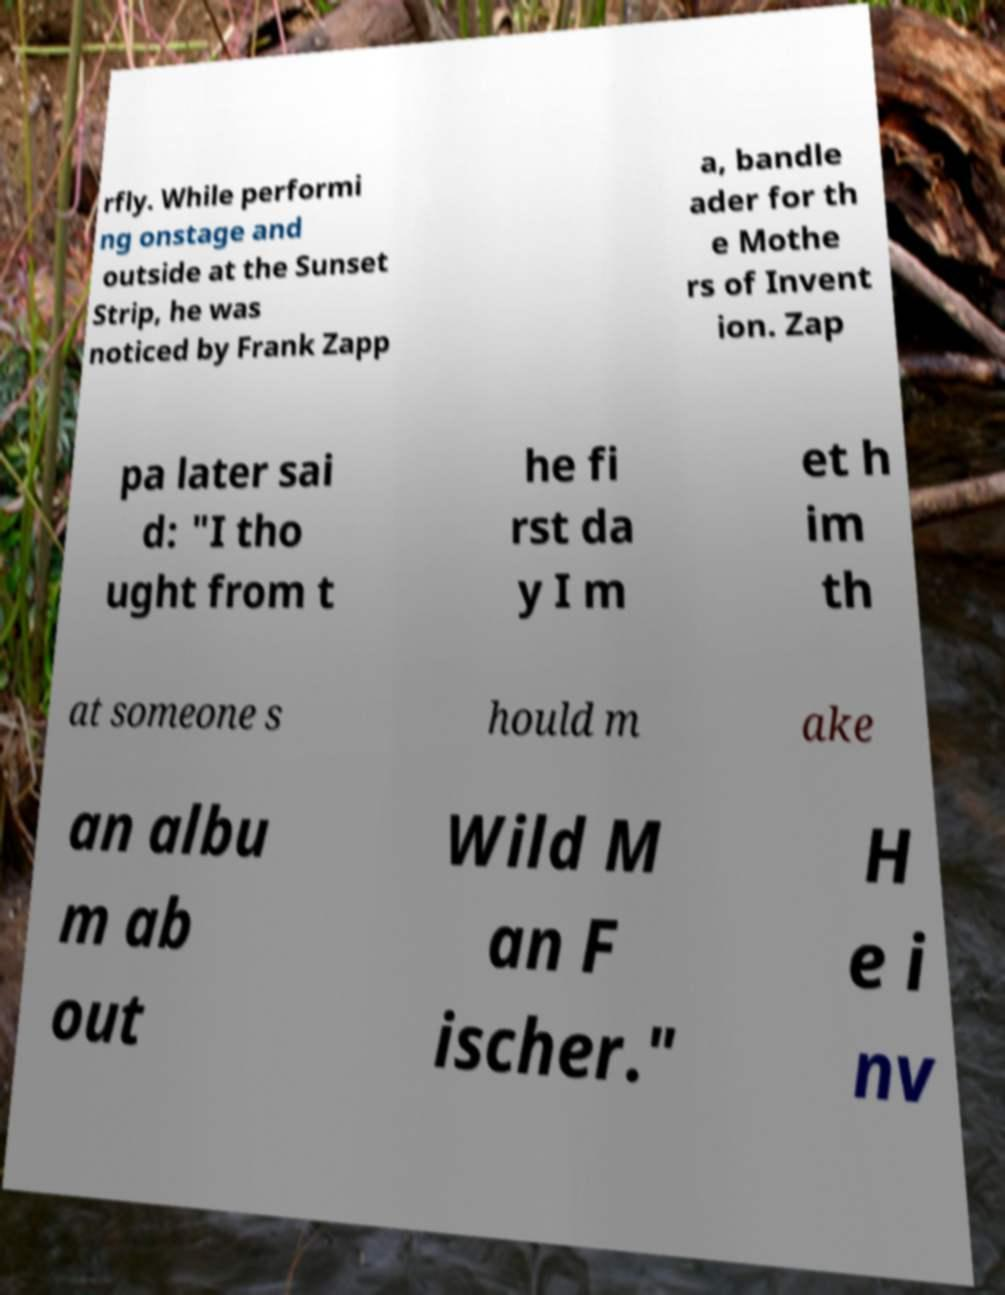Can you read and provide the text displayed in the image?This photo seems to have some interesting text. Can you extract and type it out for me? rfly. While performi ng onstage and outside at the Sunset Strip, he was noticed by Frank Zapp a, bandle ader for th e Mothe rs of Invent ion. Zap pa later sai d: "I tho ught from t he fi rst da y I m et h im th at someone s hould m ake an albu m ab out Wild M an F ischer." H e i nv 